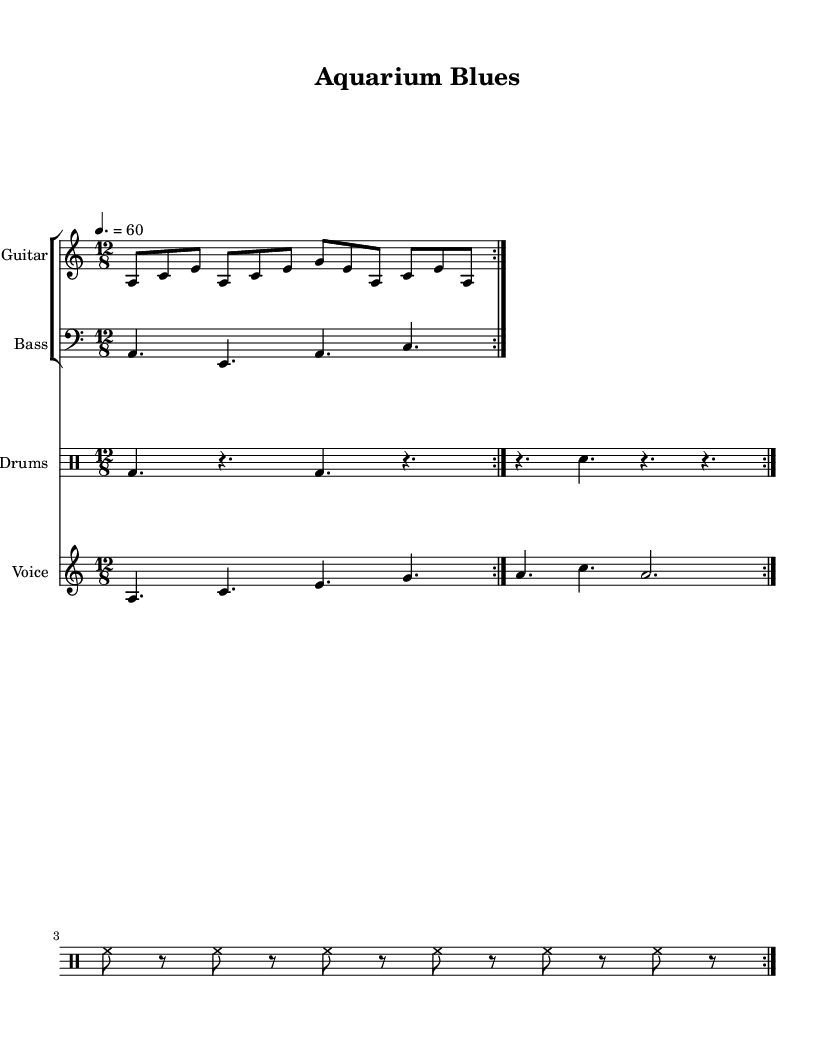What is the key signature of this music? The key signature indicates the tonal center and the notes that are sharp or flat throughout the piece. Here, the music is in A minor, which has no sharps or flats indicated in the key signature shown at the beginning of the score.
Answer: A minor What is the time signature of this music? The time signature indicates how many beats are in each measure and what note value gets one beat. In the score, the time signature is noted as 12/8, which means there are 12 eighth-note beats in each measure.
Answer: 12/8 What is the tempo marking in this piece? The tempo marking indicates how fast the music should be played. In this score, the marking shows a quarter note equals 60 beats per minute, meaning it is played slowly.
Answer: 60 How many times is the guitar riff repeated? The number of repetitions can be found in the score under the guitar part, which states that the guitar riff is repeated twice as indicated by the "repeat volta 2" notation.
Answer: 2 What are the lyrics that accompany the voice part? The lyrics are presented in the lyrics section of the score, with each line corresponding to the notes in the voice part. They convey themes of patience and progression in aquarium setup.
Answer: Slow - ly fil - ling up the tank, one drop at a time / Watch - ing bub - bles rise and fall, it's gon - na take some time What does the chorus emphasize about aquarium care? The chorus section highlights the need for patience in the hobby of aquarium care, emphasizing that building underwater worlds takes time and nothing remains static. This is captured in the phrasing of the lyrics.
Answer: Patience 